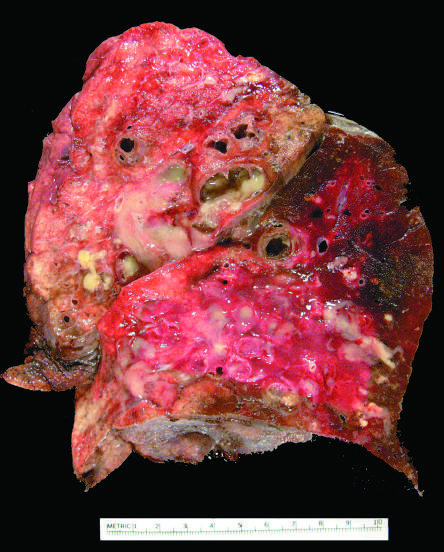what shows markedly dilated bronchi filled with purulent mucus that extend to subpleural regions?
Answer the question using a single word or phrase. Cut surface of lung 